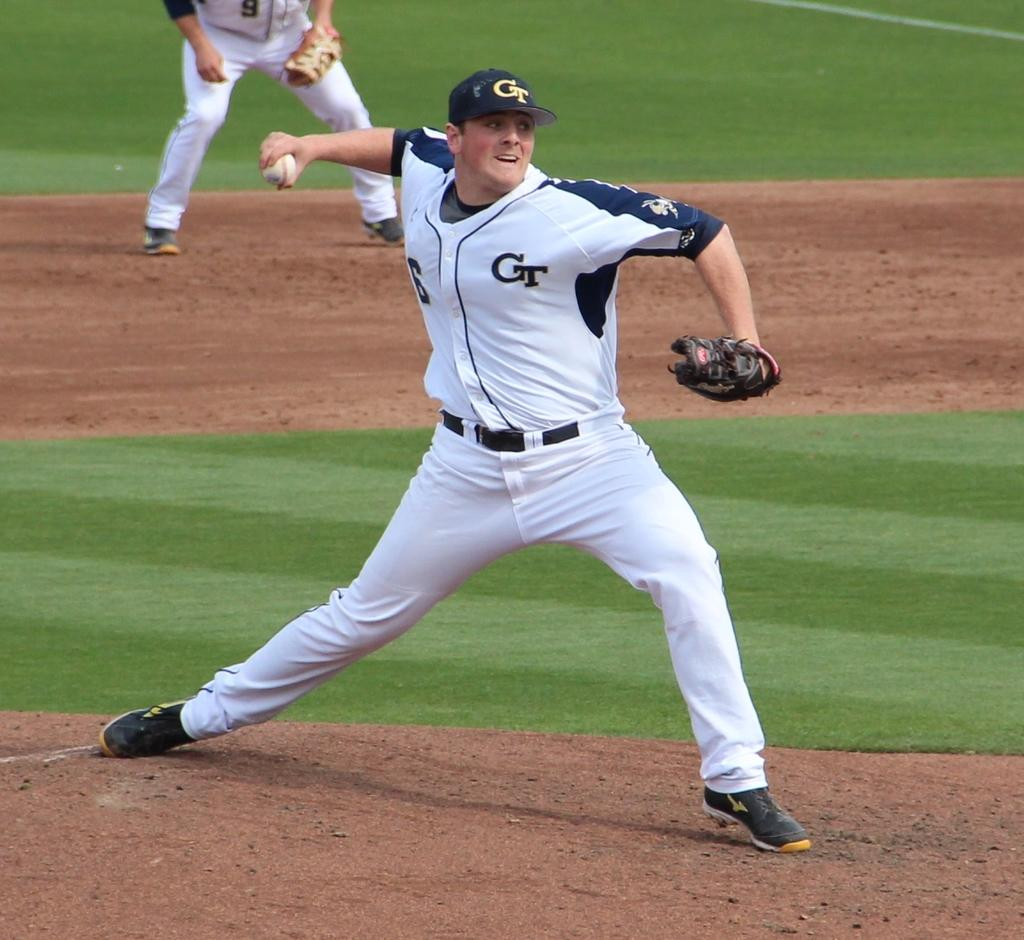<image>
Create a compact narrative representing the image presented. a pitcher on the mound in a GT jersey 